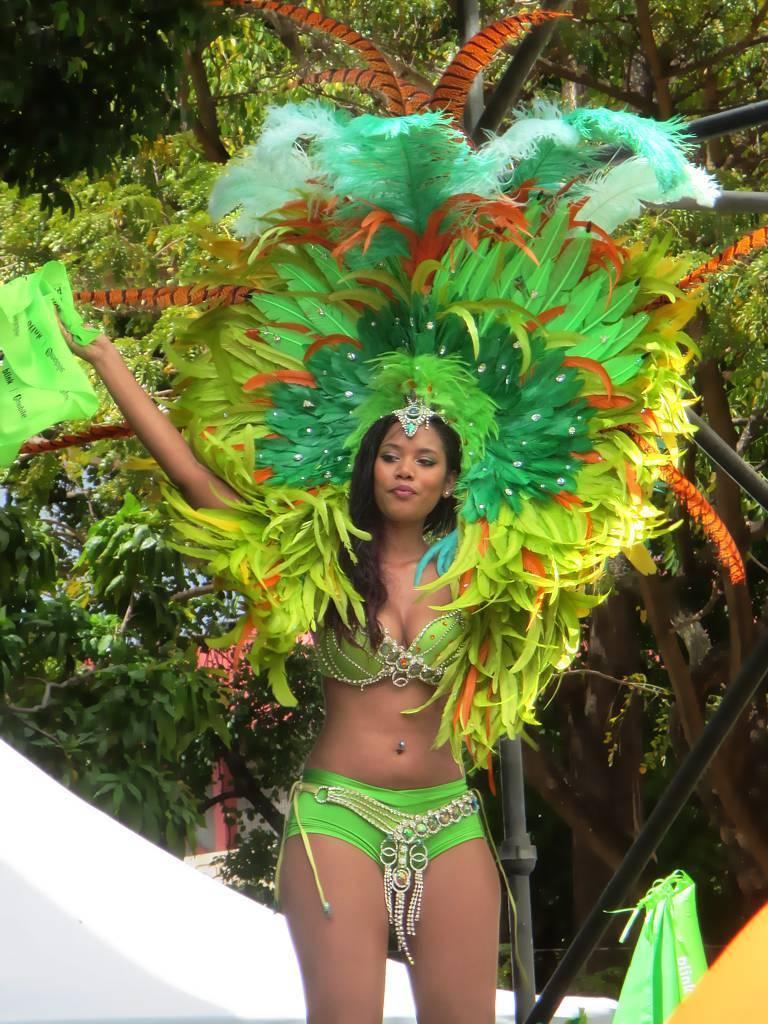Could you give a brief overview of what you see in this image? In this image, I can see the woman standing and smiling. She wore a fancy dress. In the background, I can see the trees with branches and leaves. This looks like a pole. At the bottom of the image, I think this is the wall, which is white in color. This looks like a bag, which is green in color. 